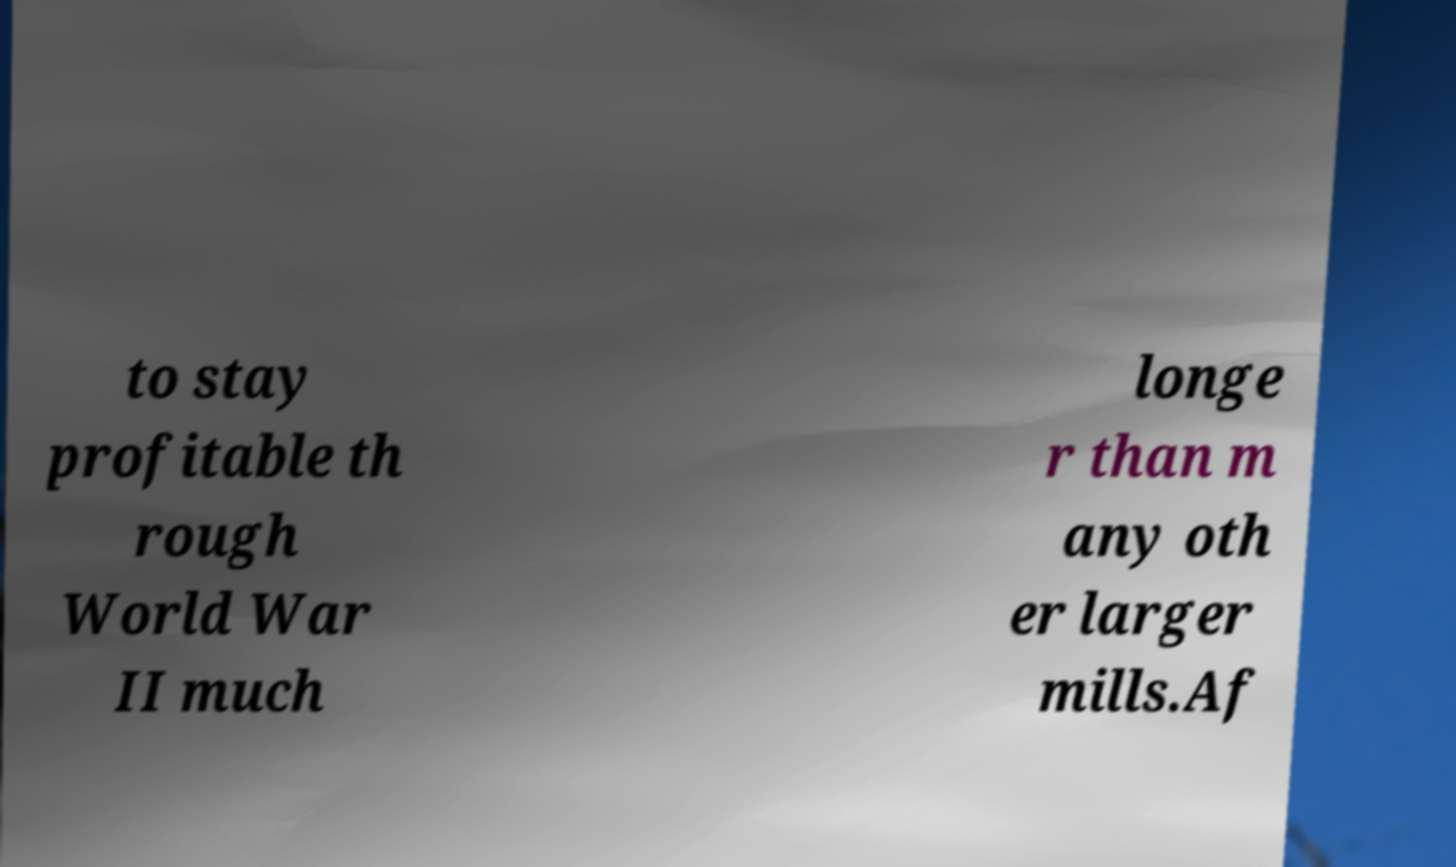There's text embedded in this image that I need extracted. Can you transcribe it verbatim? to stay profitable th rough World War II much longe r than m any oth er larger mills.Af 